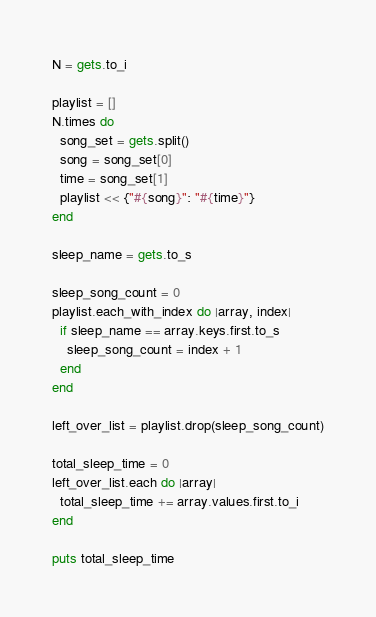Convert code to text. <code><loc_0><loc_0><loc_500><loc_500><_Ruby_>N = gets.to_i

playlist = []
N.times do 
  song_set = gets.split()
  song = song_set[0]
  time = song_set[1]
  playlist << {"#{song}": "#{time}"}
end

sleep_name = gets.to_s

sleep_song_count = 0
playlist.each_with_index do |array, index|
  if sleep_name == array.keys.first.to_s
    sleep_song_count = index + 1
  end
end

left_over_list = playlist.drop(sleep_song_count)

total_sleep_time = 0
left_over_list.each do |array|
  total_sleep_time += array.values.first.to_i
end

puts total_sleep_time
</code> 